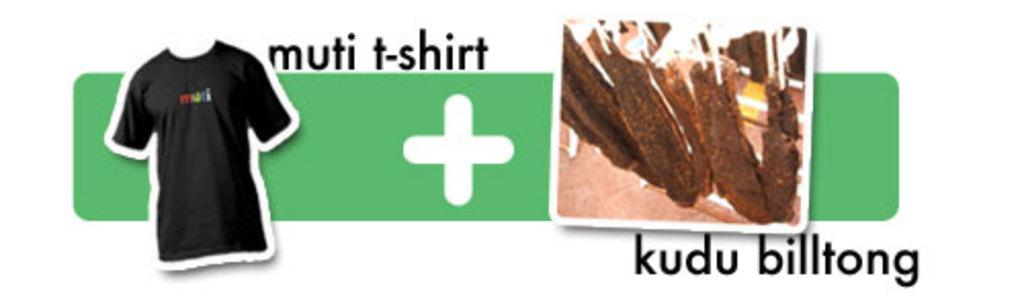<image>
Offer a succinct explanation of the picture presented. A t-shirt with a sign that says muti t-shirt + kudu billtong. 